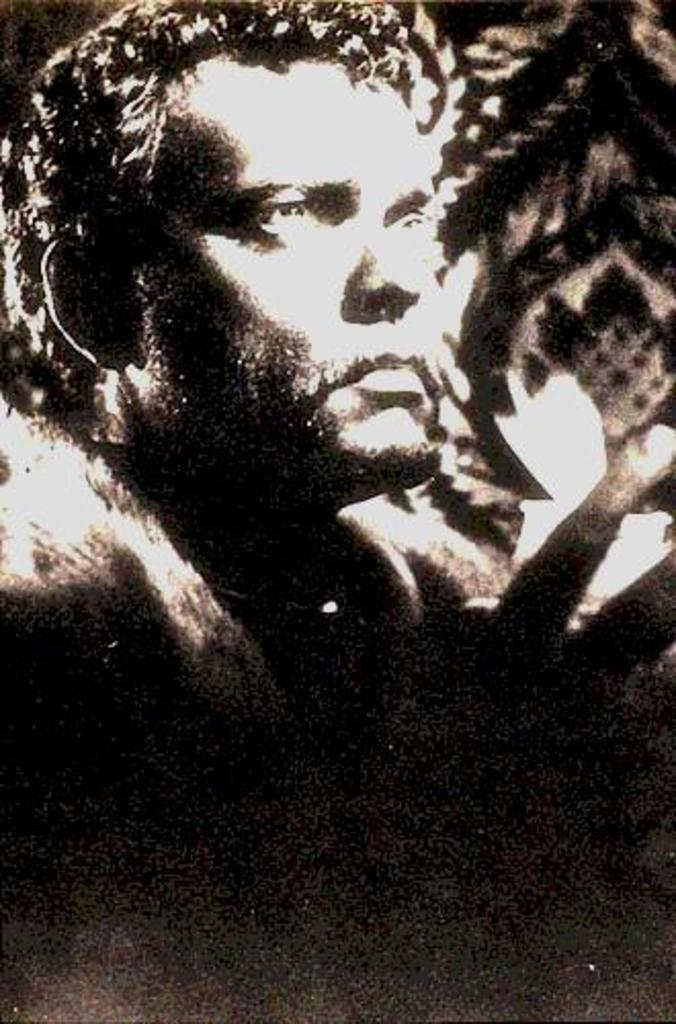What is the color scheme of the image? The image is black and white. Can you describe the main subject in the image? There is a man in the image. What type of string can be seen in the man's hand in the image? There is no string visible in the man's hand or anywhere else in the image. 